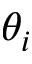Convert formula to latex. <formula><loc_0><loc_0><loc_500><loc_500>\theta _ { i }</formula> 